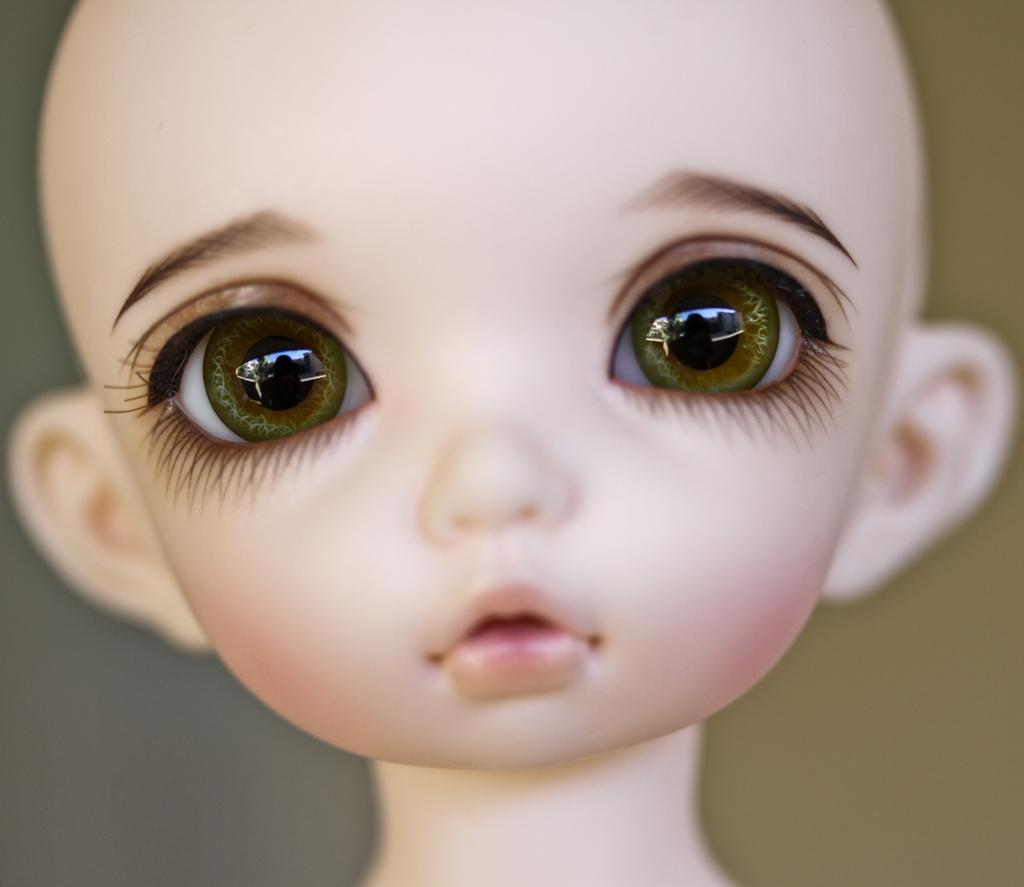What is the main subject in the image? There is a doll in the image. Can you describe the background of the image? The background of the image is colored. Where is the mother of the doll in the image? There is no mother of the doll present in the image. What type of fruit is hanging from the doll in the image? There are no fruits, such as cherries, present in the image. 